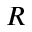<formula> <loc_0><loc_0><loc_500><loc_500>R</formula> 